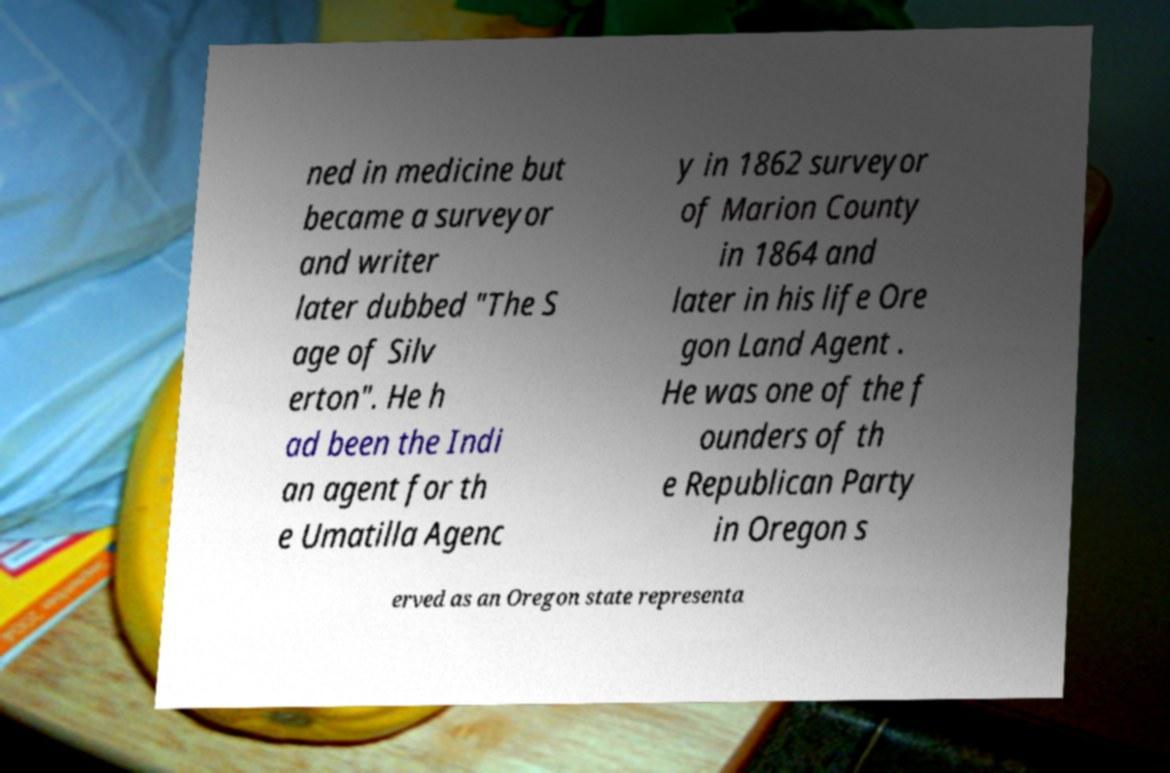There's text embedded in this image that I need extracted. Can you transcribe it verbatim? ned in medicine but became a surveyor and writer later dubbed "The S age of Silv erton". He h ad been the Indi an agent for th e Umatilla Agenc y in 1862 surveyor of Marion County in 1864 and later in his life Ore gon Land Agent . He was one of the f ounders of th e Republican Party in Oregon s erved as an Oregon state representa 